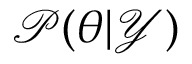Convert formula to latex. <formula><loc_0><loc_0><loc_500><loc_500>\mathcal { P } ( \theta | \mathcal { Y } )</formula> 